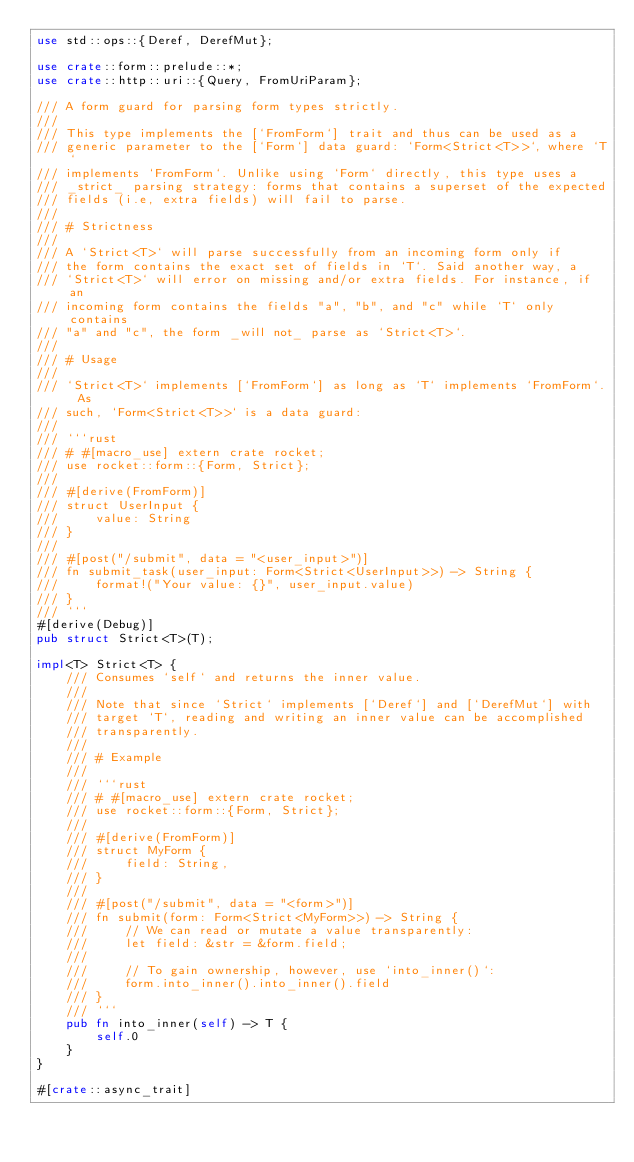Convert code to text. <code><loc_0><loc_0><loc_500><loc_500><_Rust_>use std::ops::{Deref, DerefMut};

use crate::form::prelude::*;
use crate::http::uri::{Query, FromUriParam};

/// A form guard for parsing form types strictly.
///
/// This type implements the [`FromForm`] trait and thus can be used as a
/// generic parameter to the [`Form`] data guard: `Form<Strict<T>>`, where `T`
/// implements `FromForm`. Unlike using `Form` directly, this type uses a
/// _strict_ parsing strategy: forms that contains a superset of the expected
/// fields (i.e, extra fields) will fail to parse.
///
/// # Strictness
///
/// A `Strict<T>` will parse successfully from an incoming form only if
/// the form contains the exact set of fields in `T`. Said another way, a
/// `Strict<T>` will error on missing and/or extra fields. For instance, if an
/// incoming form contains the fields "a", "b", and "c" while `T` only contains
/// "a" and "c", the form _will not_ parse as `Strict<T>`.
///
/// # Usage
///
/// `Strict<T>` implements [`FromForm`] as long as `T` implements `FromForm`. As
/// such, `Form<Strict<T>>` is a data guard:
///
/// ```rust
/// # #[macro_use] extern crate rocket;
/// use rocket::form::{Form, Strict};
///
/// #[derive(FromForm)]
/// struct UserInput {
///     value: String
/// }
///
/// #[post("/submit", data = "<user_input>")]
/// fn submit_task(user_input: Form<Strict<UserInput>>) -> String {
///     format!("Your value: {}", user_input.value)
/// }
/// ```
#[derive(Debug)]
pub struct Strict<T>(T);

impl<T> Strict<T> {
    /// Consumes `self` and returns the inner value.
    ///
    /// Note that since `Strict` implements [`Deref`] and [`DerefMut`] with
    /// target `T`, reading and writing an inner value can be accomplished
    /// transparently.
    ///
    /// # Example
    ///
    /// ```rust
    /// # #[macro_use] extern crate rocket;
    /// use rocket::form::{Form, Strict};
    ///
    /// #[derive(FromForm)]
    /// struct MyForm {
    ///     field: String,
    /// }
    ///
    /// #[post("/submit", data = "<form>")]
    /// fn submit(form: Form<Strict<MyForm>>) -> String {
    ///     // We can read or mutate a value transparently:
    ///     let field: &str = &form.field;
    ///
    ///     // To gain ownership, however, use `into_inner()`:
    ///     form.into_inner().into_inner().field
    /// }
    /// ```
    pub fn into_inner(self) -> T {
        self.0
    }
}

#[crate::async_trait]</code> 